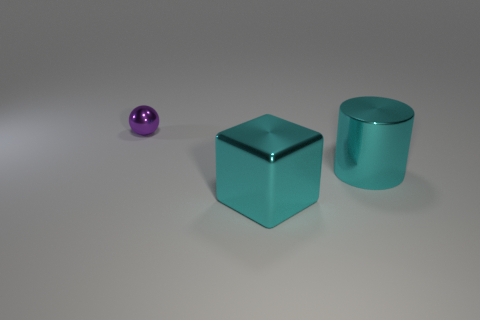Add 1 cylinders. How many objects exist? 4 Subtract all cylinders. How many objects are left? 2 Subtract 1 cyan blocks. How many objects are left? 2 Subtract all tiny blue rubber cylinders. Subtract all cyan cylinders. How many objects are left? 2 Add 1 large blocks. How many large blocks are left? 2 Add 3 big objects. How many big objects exist? 5 